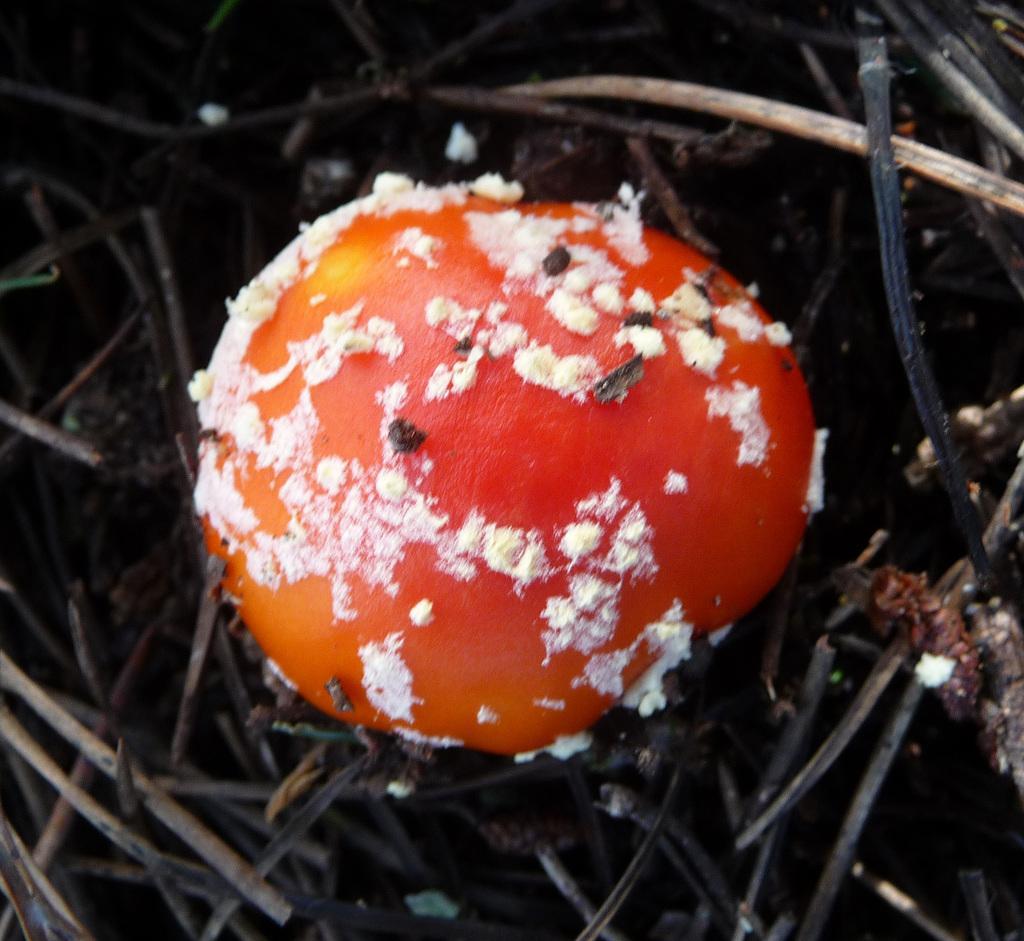How would you summarize this image in a sentence or two? We can see mushroom and wooden sticks. 